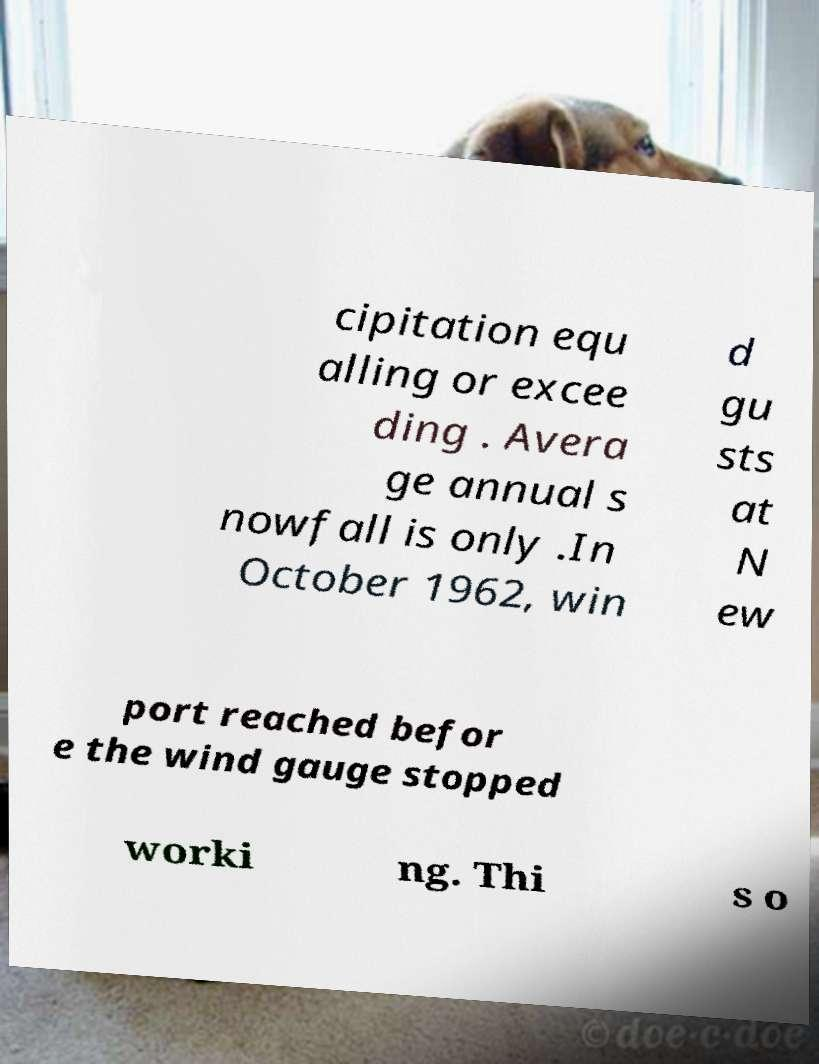Can you accurately transcribe the text from the provided image for me? cipitation equ alling or excee ding . Avera ge annual s nowfall is only .In October 1962, win d gu sts at N ew port reached befor e the wind gauge stopped worki ng. Thi s o 